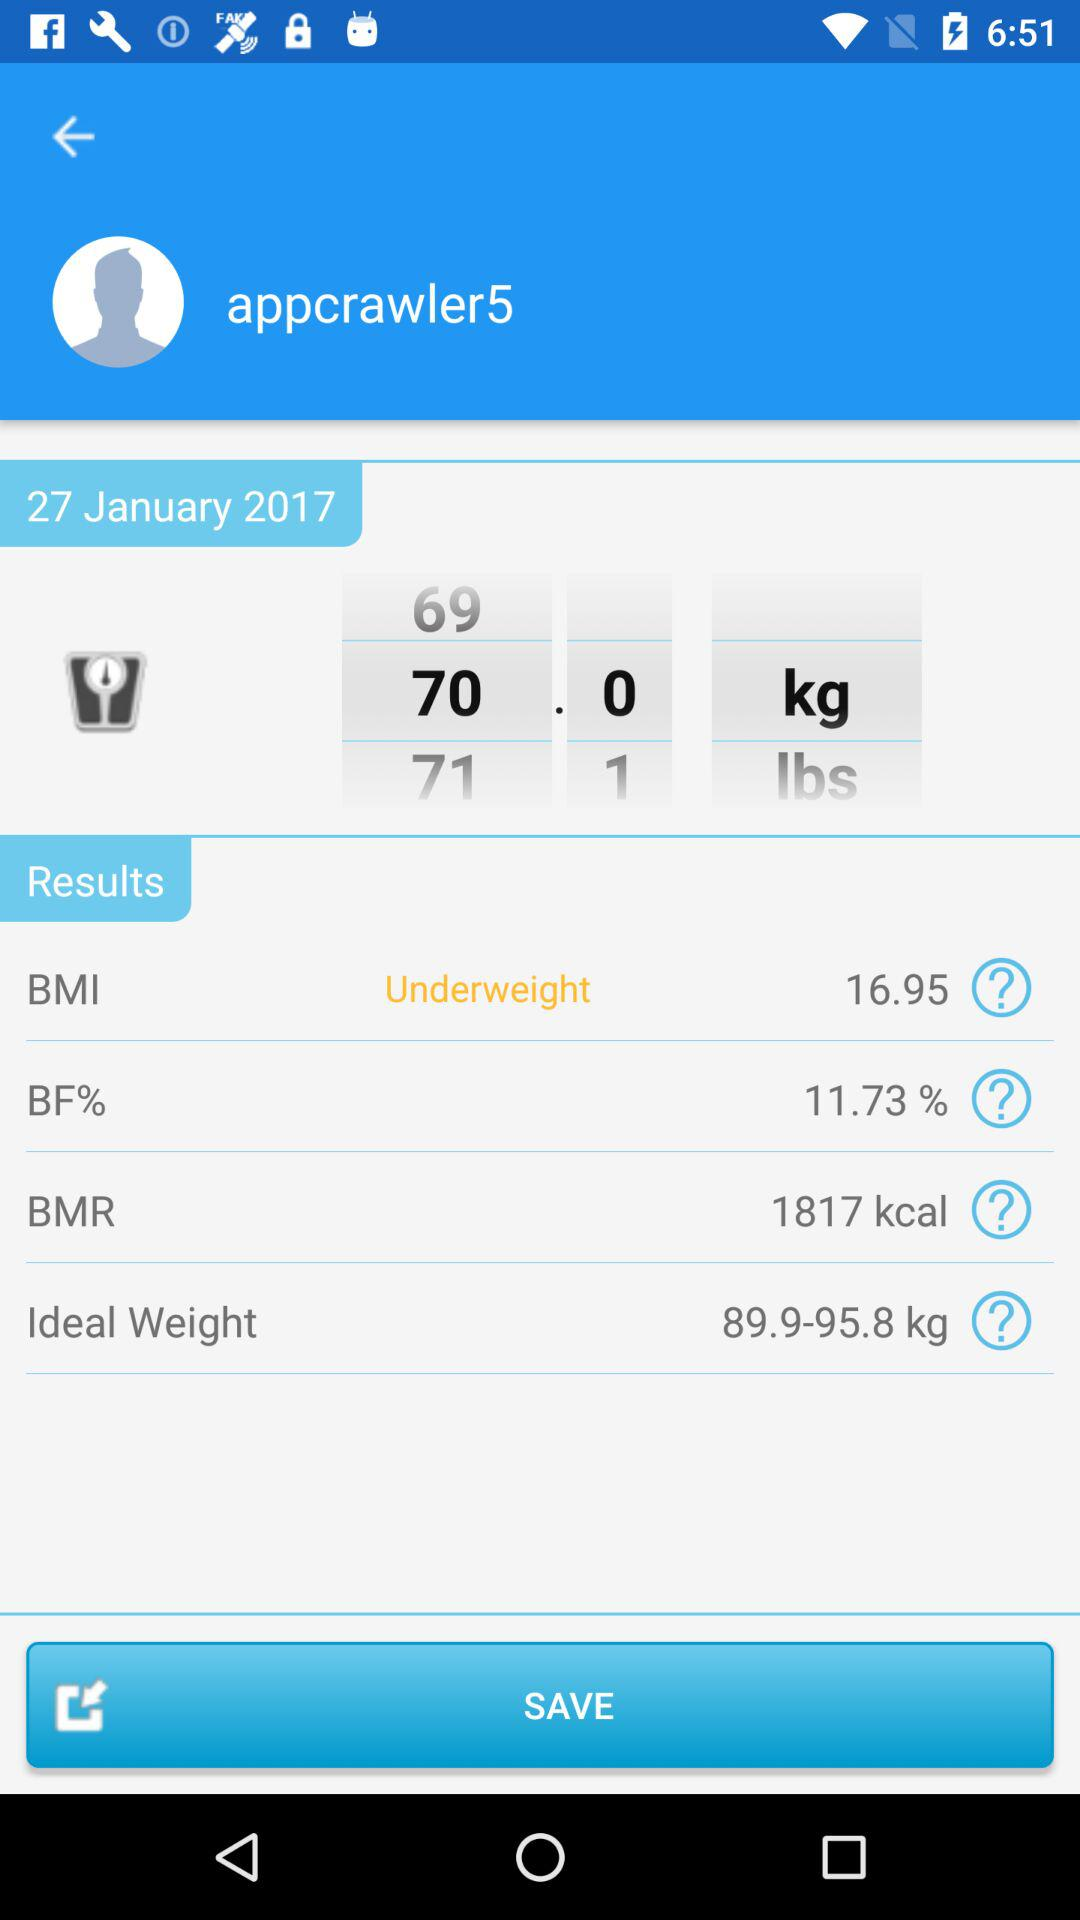What is the mentioned date? The mentioned date is January 27, 2017. 